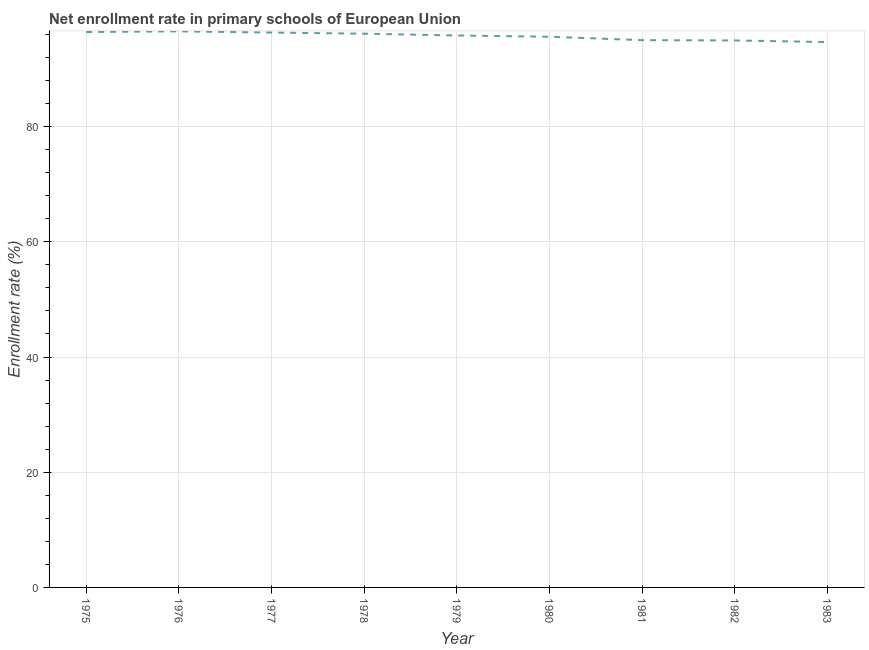What is the net enrollment rate in primary schools in 1975?
Keep it short and to the point. 96.42. Across all years, what is the maximum net enrollment rate in primary schools?
Your answer should be very brief. 96.53. Across all years, what is the minimum net enrollment rate in primary schools?
Your answer should be very brief. 94.67. In which year was the net enrollment rate in primary schools maximum?
Provide a short and direct response. 1976. In which year was the net enrollment rate in primary schools minimum?
Offer a very short reply. 1983. What is the sum of the net enrollment rate in primary schools?
Your answer should be compact. 861.46. What is the difference between the net enrollment rate in primary schools in 1975 and 1977?
Provide a short and direct response. 0.1. What is the average net enrollment rate in primary schools per year?
Provide a short and direct response. 95.72. What is the median net enrollment rate in primary schools?
Your answer should be very brief. 95.82. What is the ratio of the net enrollment rate in primary schools in 1978 to that in 1982?
Your answer should be very brief. 1.01. Is the difference between the net enrollment rate in primary schools in 1975 and 1981 greater than the difference between any two years?
Provide a short and direct response. No. What is the difference between the highest and the second highest net enrollment rate in primary schools?
Keep it short and to the point. 0.12. Is the sum of the net enrollment rate in primary schools in 1976 and 1979 greater than the maximum net enrollment rate in primary schools across all years?
Offer a terse response. Yes. What is the difference between the highest and the lowest net enrollment rate in primary schools?
Provide a succinct answer. 1.86. In how many years, is the net enrollment rate in primary schools greater than the average net enrollment rate in primary schools taken over all years?
Keep it short and to the point. 5. Does the net enrollment rate in primary schools monotonically increase over the years?
Offer a terse response. No. Does the graph contain grids?
Your response must be concise. Yes. What is the title of the graph?
Keep it short and to the point. Net enrollment rate in primary schools of European Union. What is the label or title of the Y-axis?
Offer a terse response. Enrollment rate (%). What is the Enrollment rate (%) of 1975?
Provide a short and direct response. 96.42. What is the Enrollment rate (%) of 1976?
Offer a terse response. 96.53. What is the Enrollment rate (%) in 1977?
Your response must be concise. 96.32. What is the Enrollment rate (%) of 1978?
Offer a terse response. 96.13. What is the Enrollment rate (%) of 1979?
Keep it short and to the point. 95.82. What is the Enrollment rate (%) in 1980?
Your response must be concise. 95.6. What is the Enrollment rate (%) of 1981?
Your answer should be compact. 95.01. What is the Enrollment rate (%) in 1982?
Provide a succinct answer. 94.96. What is the Enrollment rate (%) of 1983?
Offer a very short reply. 94.67. What is the difference between the Enrollment rate (%) in 1975 and 1976?
Offer a very short reply. -0.12. What is the difference between the Enrollment rate (%) in 1975 and 1977?
Make the answer very short. 0.1. What is the difference between the Enrollment rate (%) in 1975 and 1978?
Give a very brief answer. 0.28. What is the difference between the Enrollment rate (%) in 1975 and 1979?
Keep it short and to the point. 0.6. What is the difference between the Enrollment rate (%) in 1975 and 1980?
Make the answer very short. 0.82. What is the difference between the Enrollment rate (%) in 1975 and 1981?
Keep it short and to the point. 1.41. What is the difference between the Enrollment rate (%) in 1975 and 1982?
Offer a terse response. 1.46. What is the difference between the Enrollment rate (%) in 1975 and 1983?
Ensure brevity in your answer.  1.74. What is the difference between the Enrollment rate (%) in 1976 and 1977?
Offer a terse response. 0.21. What is the difference between the Enrollment rate (%) in 1976 and 1978?
Ensure brevity in your answer.  0.4. What is the difference between the Enrollment rate (%) in 1976 and 1979?
Keep it short and to the point. 0.72. What is the difference between the Enrollment rate (%) in 1976 and 1980?
Give a very brief answer. 0.93. What is the difference between the Enrollment rate (%) in 1976 and 1981?
Offer a terse response. 1.53. What is the difference between the Enrollment rate (%) in 1976 and 1982?
Provide a succinct answer. 1.58. What is the difference between the Enrollment rate (%) in 1976 and 1983?
Your answer should be compact. 1.86. What is the difference between the Enrollment rate (%) in 1977 and 1978?
Your answer should be compact. 0.19. What is the difference between the Enrollment rate (%) in 1977 and 1979?
Make the answer very short. 0.51. What is the difference between the Enrollment rate (%) in 1977 and 1980?
Give a very brief answer. 0.72. What is the difference between the Enrollment rate (%) in 1977 and 1981?
Your answer should be compact. 1.31. What is the difference between the Enrollment rate (%) in 1977 and 1982?
Your answer should be very brief. 1.36. What is the difference between the Enrollment rate (%) in 1977 and 1983?
Offer a very short reply. 1.65. What is the difference between the Enrollment rate (%) in 1978 and 1979?
Offer a terse response. 0.32. What is the difference between the Enrollment rate (%) in 1978 and 1980?
Your answer should be compact. 0.53. What is the difference between the Enrollment rate (%) in 1978 and 1981?
Provide a short and direct response. 1.13. What is the difference between the Enrollment rate (%) in 1978 and 1982?
Keep it short and to the point. 1.17. What is the difference between the Enrollment rate (%) in 1978 and 1983?
Keep it short and to the point. 1.46. What is the difference between the Enrollment rate (%) in 1979 and 1980?
Offer a terse response. 0.21. What is the difference between the Enrollment rate (%) in 1979 and 1981?
Provide a short and direct response. 0.81. What is the difference between the Enrollment rate (%) in 1979 and 1982?
Keep it short and to the point. 0.86. What is the difference between the Enrollment rate (%) in 1979 and 1983?
Provide a short and direct response. 1.14. What is the difference between the Enrollment rate (%) in 1980 and 1981?
Your answer should be very brief. 0.59. What is the difference between the Enrollment rate (%) in 1980 and 1982?
Keep it short and to the point. 0.64. What is the difference between the Enrollment rate (%) in 1980 and 1983?
Offer a very short reply. 0.93. What is the difference between the Enrollment rate (%) in 1981 and 1982?
Keep it short and to the point. 0.05. What is the difference between the Enrollment rate (%) in 1981 and 1983?
Provide a succinct answer. 0.33. What is the difference between the Enrollment rate (%) in 1982 and 1983?
Provide a short and direct response. 0.28. What is the ratio of the Enrollment rate (%) in 1975 to that in 1976?
Offer a terse response. 1. What is the ratio of the Enrollment rate (%) in 1975 to that in 1978?
Your response must be concise. 1. What is the ratio of the Enrollment rate (%) in 1975 to that in 1980?
Your answer should be very brief. 1.01. What is the ratio of the Enrollment rate (%) in 1976 to that in 1977?
Provide a short and direct response. 1. What is the ratio of the Enrollment rate (%) in 1976 to that in 1978?
Ensure brevity in your answer.  1. What is the ratio of the Enrollment rate (%) in 1976 to that in 1979?
Keep it short and to the point. 1.01. What is the ratio of the Enrollment rate (%) in 1976 to that in 1981?
Your answer should be compact. 1.02. What is the ratio of the Enrollment rate (%) in 1976 to that in 1983?
Your answer should be compact. 1.02. What is the ratio of the Enrollment rate (%) in 1977 to that in 1980?
Offer a terse response. 1.01. What is the ratio of the Enrollment rate (%) in 1977 to that in 1982?
Provide a short and direct response. 1.01. What is the ratio of the Enrollment rate (%) in 1977 to that in 1983?
Give a very brief answer. 1.02. What is the ratio of the Enrollment rate (%) in 1978 to that in 1979?
Your answer should be compact. 1. What is the ratio of the Enrollment rate (%) in 1978 to that in 1981?
Provide a succinct answer. 1.01. What is the ratio of the Enrollment rate (%) in 1978 to that in 1983?
Keep it short and to the point. 1.01. What is the ratio of the Enrollment rate (%) in 1979 to that in 1980?
Provide a short and direct response. 1. What is the ratio of the Enrollment rate (%) in 1979 to that in 1981?
Make the answer very short. 1.01. What is the ratio of the Enrollment rate (%) in 1979 to that in 1983?
Offer a very short reply. 1.01. What is the ratio of the Enrollment rate (%) in 1980 to that in 1983?
Give a very brief answer. 1.01. What is the ratio of the Enrollment rate (%) in 1981 to that in 1983?
Keep it short and to the point. 1. 